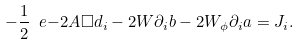<formula> <loc_0><loc_0><loc_500><loc_500>- \frac { 1 } { 2 } \ e { - 2 A } \Box d _ { i } - 2 W \partial _ { i } b - 2 W _ { \phi } \partial _ { i } a = J _ { i } .</formula> 